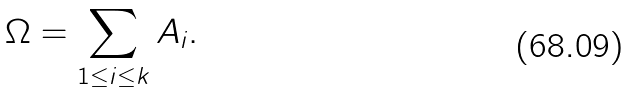<formula> <loc_0><loc_0><loc_500><loc_500>\Omega = \sum _ { 1 \leq i \leq k } A _ { i } .</formula> 